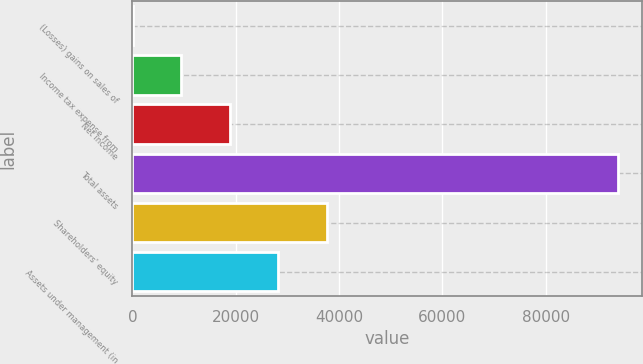Convert chart. <chart><loc_0><loc_0><loc_500><loc_500><bar_chart><fcel>(Losses) gains on sales of<fcel>Income tax expense from<fcel>Net income<fcel>Total assets<fcel>Shareholders' equity<fcel>Assets under management (in<nl><fcel>26<fcel>9427.4<fcel>18828.8<fcel>94040<fcel>37631.6<fcel>28230.2<nl></chart> 